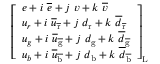<formula> <loc_0><loc_0><loc_500><loc_500>{ \left [ \begin{array} { l } { e + i \ { \overline { e } } + j \ v + k \ { \overline { v } } } \\ { u _ { r } + i \ { \overline { u } } _ { \overline { r } } + j \ d _ { r } + k \ { \overline { d } } _ { \overline { r } } } \\ { u _ { g } + i \ { \overline { u } } _ { \overline { g } } + j \ d _ { g } + k \ { \overline { d } } _ { \overline { g } } } \\ { u _ { b } + i \ { \overline { u } } _ { \overline { b } } + j \ d _ { b } + k \ { \overline { d } } _ { \overline { b } } } \end{array} \right ] } _ { L }</formula> 